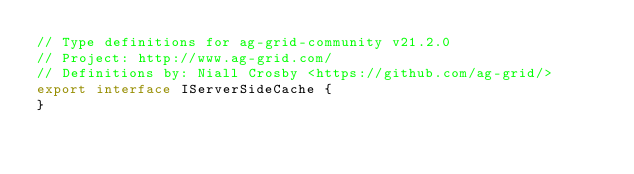<code> <loc_0><loc_0><loc_500><loc_500><_TypeScript_>// Type definitions for ag-grid-community v21.2.0
// Project: http://www.ag-grid.com/
// Definitions by: Niall Crosby <https://github.com/ag-grid/>
export interface IServerSideCache {
}
</code> 